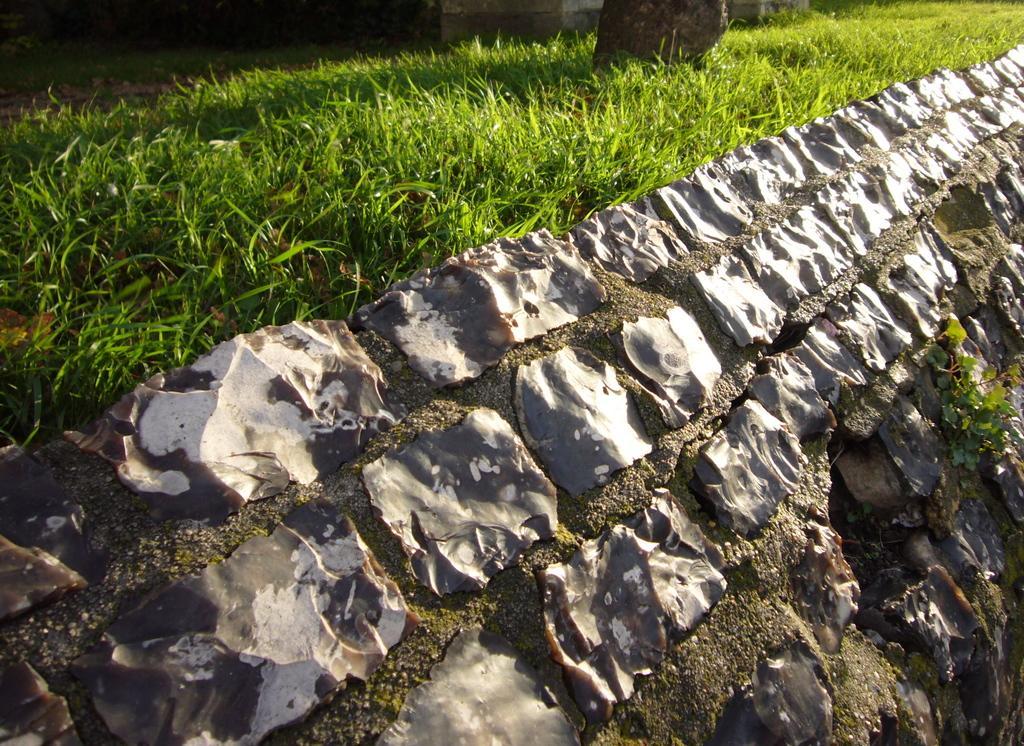In one or two sentences, can you explain what this image depicts? In this image we can see grass and other objects. At the bottom of the image there is a plant and they are looking like stones on a surface. 